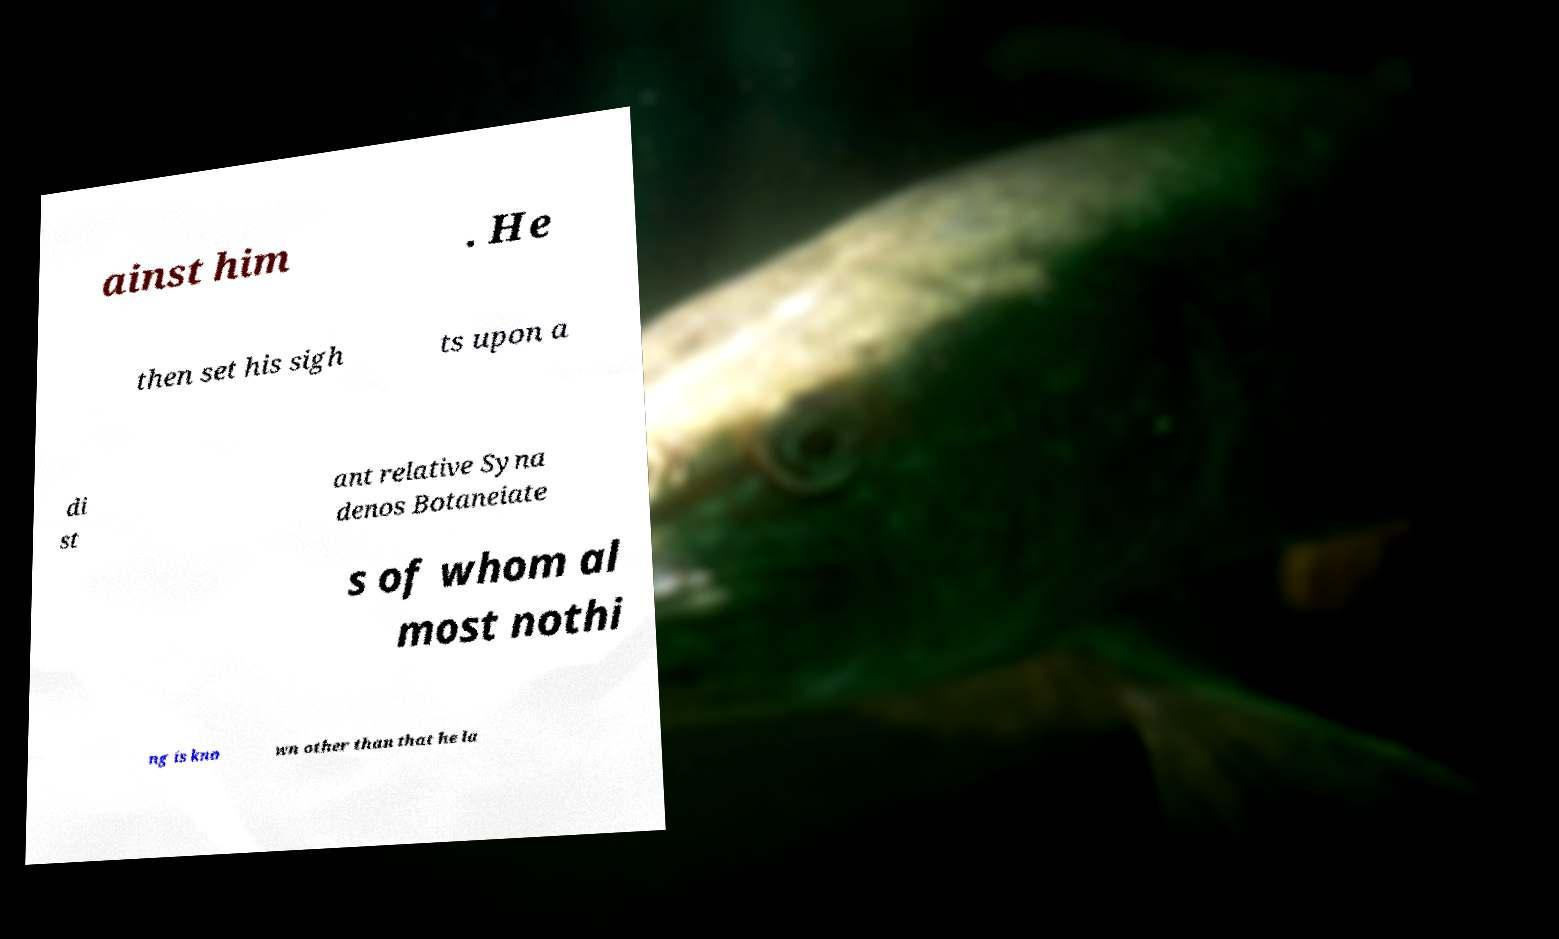Can you accurately transcribe the text from the provided image for me? ainst him . He then set his sigh ts upon a di st ant relative Syna denos Botaneiate s of whom al most nothi ng is kno wn other than that he la 